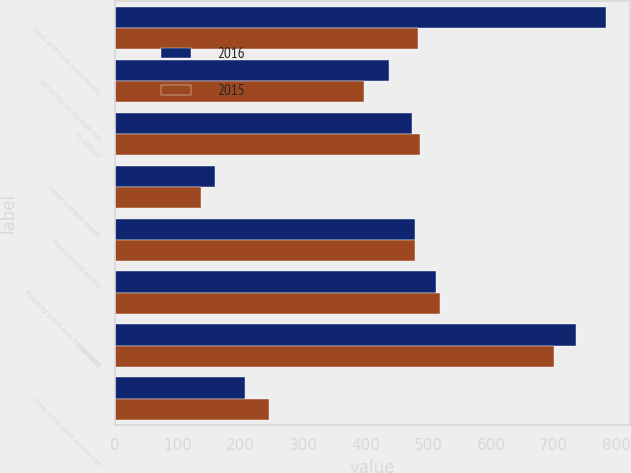<chart> <loc_0><loc_0><loc_500><loc_500><stacked_bar_chart><ecel><fcel>Cash and cash equivalents<fcel>Accounts receivable net<fcel>Inventory<fcel>Other current assets<fcel>Total current assets<fcel>Property plant and equipment<fcel>Goodwill<fcel>Other intangible assets net<nl><fcel>2016<fcel>783<fcel>437<fcel>474<fcel>160<fcel>478.5<fcel>512<fcel>736<fcel>208<nl><fcel>2015<fcel>483<fcel>398<fcel>487<fcel>137<fcel>478.5<fcel>518<fcel>700<fcel>246<nl></chart> 